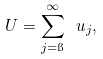<formula> <loc_0><loc_0><loc_500><loc_500>U = \sum _ { j = \i } ^ { \infty } \ u _ { j } ,</formula> 